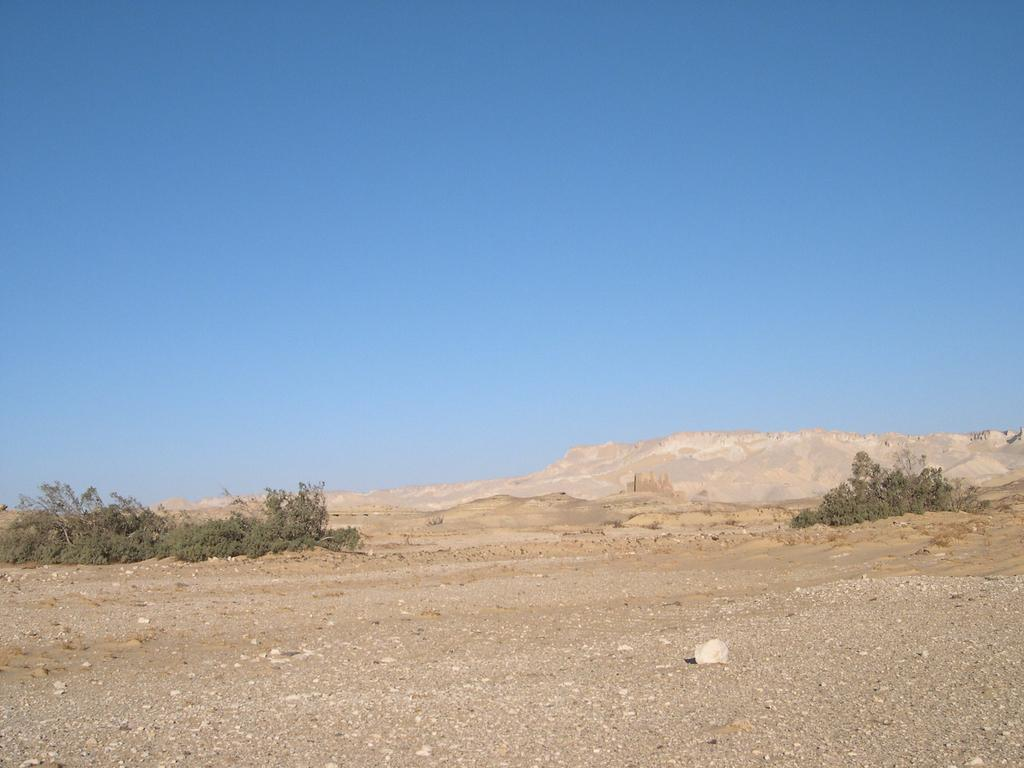What type of surface is visible in the image? There is ground visible in the image. What other natural elements can be seen in the image? There are plants and a hill in the image. What is visible in the background of the image? The sky is visible in the background of the image. What is the color of the sky in the image? The color of the sky is blue. Where is the dock located in the image? There is no dock present in the image. What type of stem can be seen growing from the plants in the image? There is no stem visible in the image, as only the plants themselves are shown. 